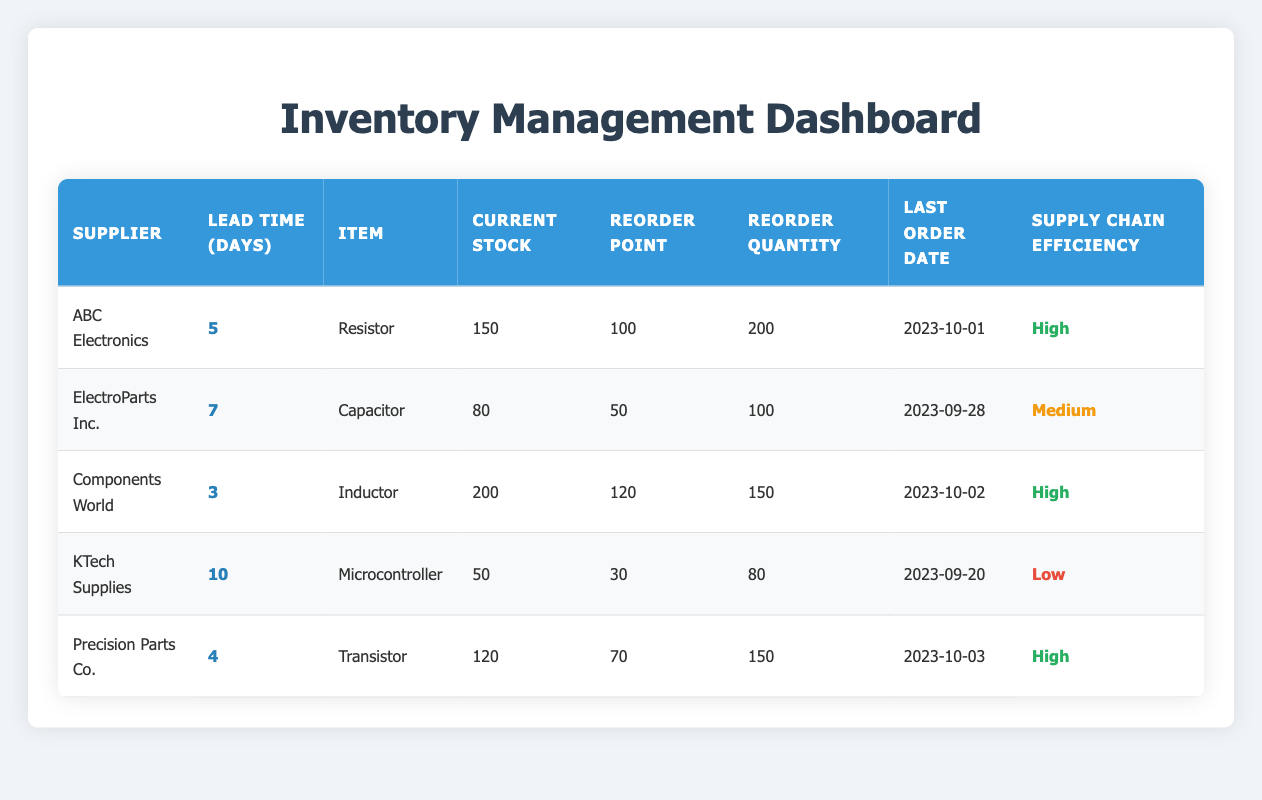What is the current stock of the "Capacitor"? The table indicates that the current stock for the "Capacitor" is listed directly under the "Current Stock" column. According to the data, it shows a value of 80.
Answer: 80 Which supplier has the highest lead time? To determine this, I will compare the lead times from the "Lead Time (Days)" column. Upon inspection, "KTech Supplies" has a lead time of 10 days, which is greater than all other suppliers listed in the table.
Answer: KTech Supplies How many total days of lead time do the suppliers collectively have? To find the total lead time, I will sum the individual lead times from each supplier: 5 (ABC Electronics) + 7 (ElectroParts Inc.) + 3 (Components World) + 10 (KTech Supplies) + 4 (Precision Parts Co.) = 29 days.
Answer: 29 Is the supply chain efficiency of "Precision Parts Co." high? According to the table, the supply chain efficiency for "Precision Parts Co." is noted under the "Supply Chain Efficiency" column, which indicates a rating of "High." Hence, this query can be confirmed as true.
Answer: Yes What is the difference in current stock between the "Microcontroller" and the "Inductor"? I will subtract the current stock of the "Microcontroller" (50) from the current stock of the "Inductor" (200). Therefore, the calculation is 200 - 50 = 150.
Answer: 150 How many items have a reorder point less than 100? I will evaluate the "Reorder Point" column for each item. The reorder points are 100 (Resistor), 50 (Capacitor), 120 (Inductor), 30 (Microcontroller), and 70 (Transistor). Only the "Capacitor" (50) and "Microcontroller" (30) have a reorder point less than 100, making a total of 2 items.
Answer: 2 Which supplier's item requires the largest reorder quantity? I will look at the "Reorder Quantity" column and identify the maximum value. The values present are 200 (Resistor), 100 (Capacitor), 150 (Inductor), 80 (Microcontroller), and 150 (Transistor). The highest value is 200 for the "Resistor," supplied by "ABC Electronics."
Answer: ABC Electronics Does "Components World" have a lead time shorter than 5 days? The lead time for "Components World" is explicitly mentioned as 3 days in the "Lead Time (Days)" column. Therefore, this statement is true as 3 is indeed less than 5.
Answer: No What is the average lead time across all suppliers? To obtain the average lead time, I will first sum the lead times: (5 + 7 + 3 + 10 + 4) = 29 days. There are 5 suppliers, so I will divide the total by 5, giving me an average of 29/5 = 5.8 days.
Answer: 5.8 